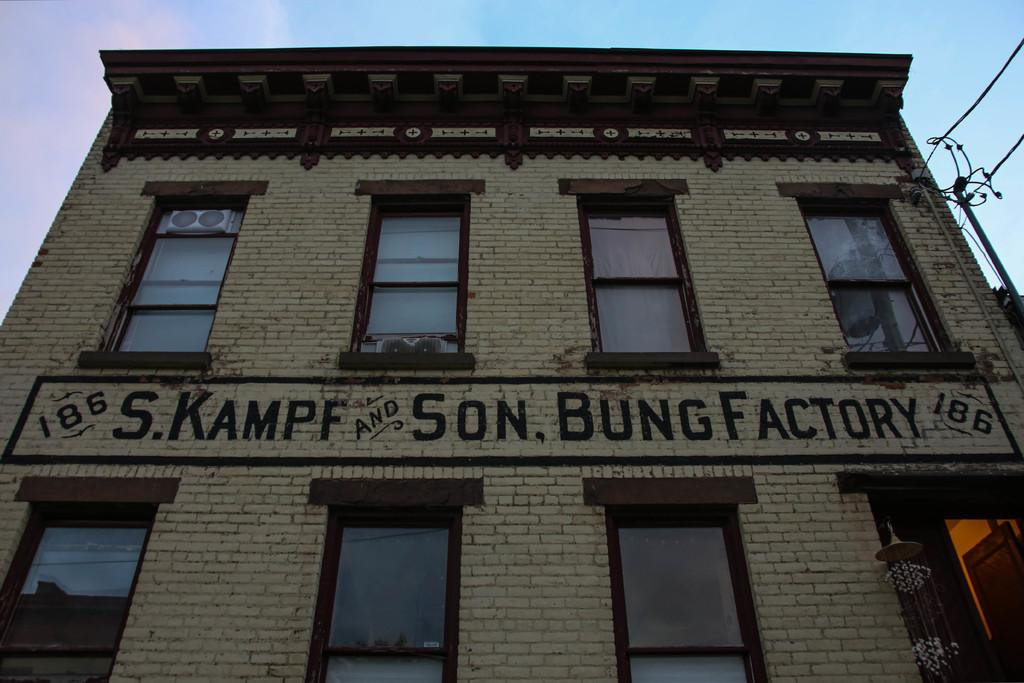What structure is the main subject of the image? There is a building in the image. What can be seen behind the building? There are poles and wires behind the building. What type of natural elements are visible in the image? There are clouds visible in the image. What is visible in the background of the image? The sky is visible in the image. What type of pancake is being flipped in the image? There is no pancake present in the image; it features a building with poles and wires behind it, clouds, and the sky. What record is being played in the image? There is no record or any indication of music playing in the image. 